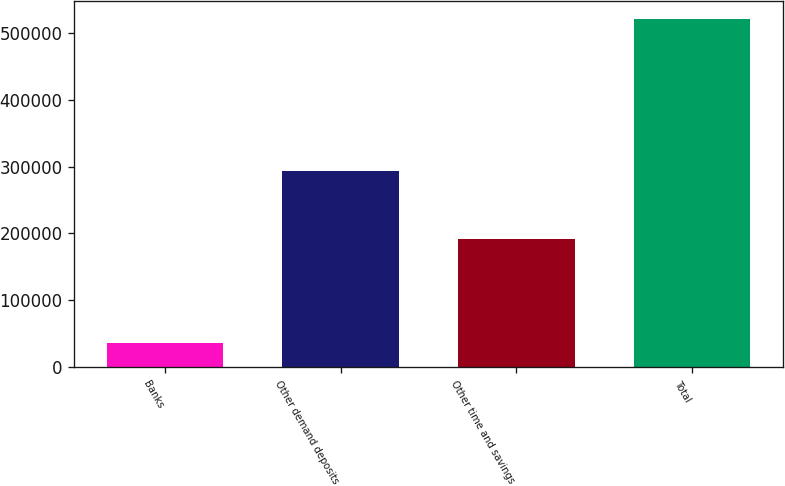<chart> <loc_0><loc_0><loc_500><loc_500><bar_chart><fcel>Banks<fcel>Other demand deposits<fcel>Other time and savings<fcel>Total<nl><fcel>36063<fcel>293389<fcel>191363<fcel>520815<nl></chart> 